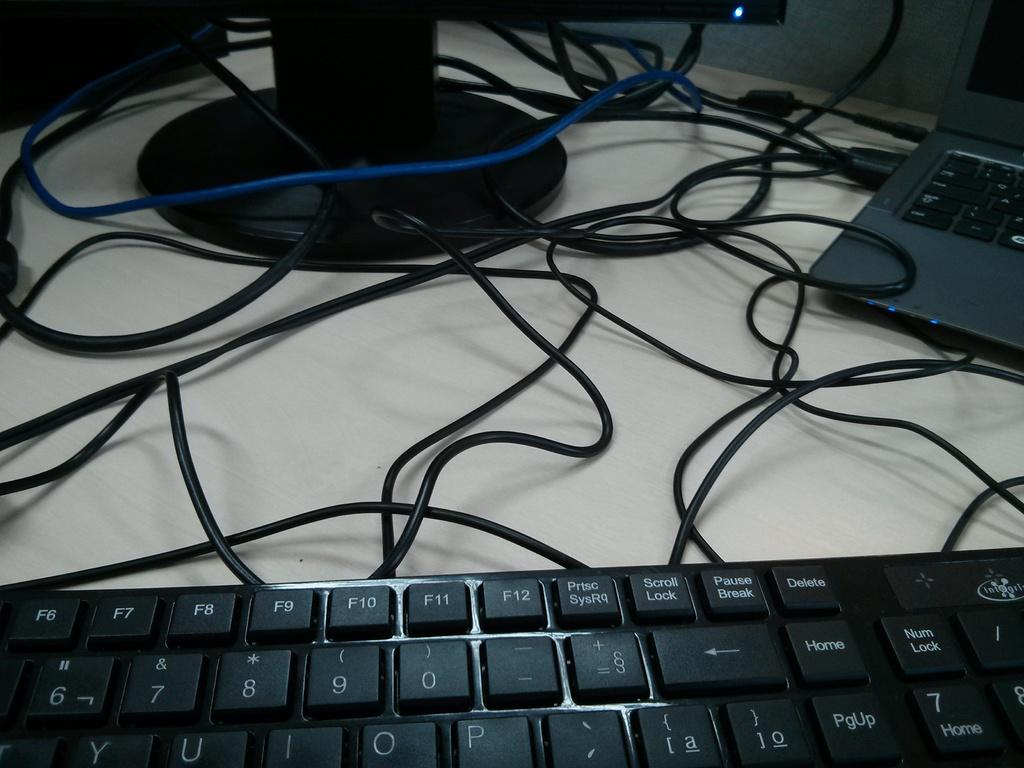<image>
Provide a brief description of the given image. Half of a computer keyboard showing including the numbers 6,7,8,9, and 0 